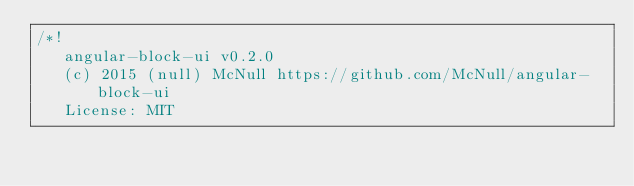Convert code to text. <code><loc_0><loc_0><loc_500><loc_500><_CSS_>/*!
   angular-block-ui v0.2.0
   (c) 2015 (null) McNull https://github.com/McNull/angular-block-ui
   License: MIT</code> 